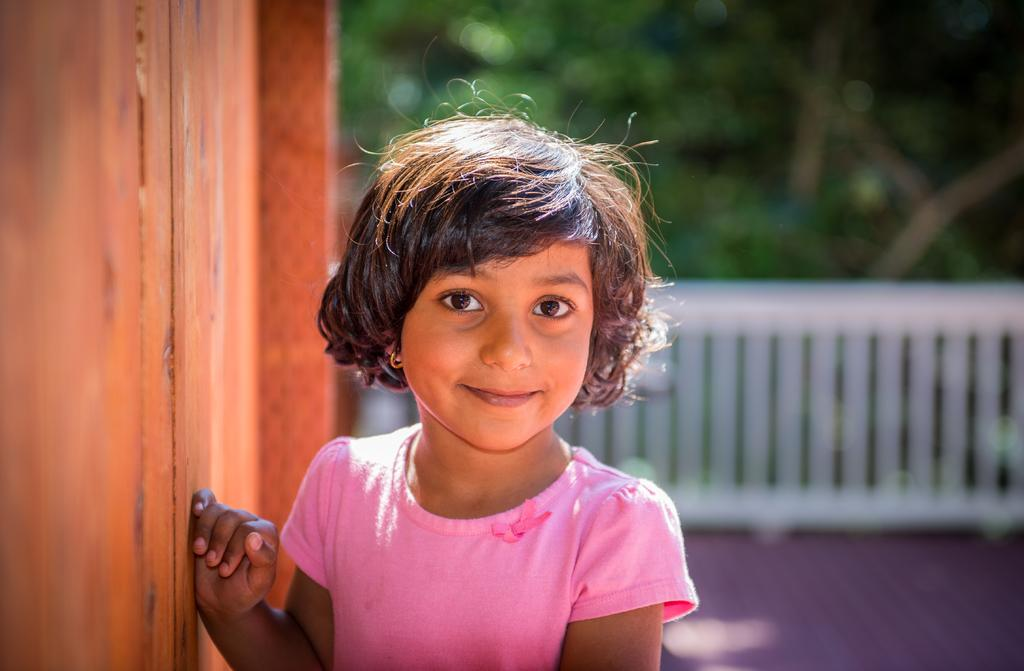Who is present in the image? There is a girl in the image. What is the girl doing in the image? The girl is standing beside a wall. What can be seen in the background of the image? There is a fence in the background of the image, and beside the fence, there are trees. What type of suit is the girl wearing in the image? There is no suit present in the image; the girl is not wearing any clothing mentioned in the facts. 